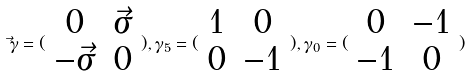Convert formula to latex. <formula><loc_0><loc_0><loc_500><loc_500>\vec { \gamma } = ( \begin{array} { c c } 0 & \vec { \sigma } \\ - \vec { \sigma } & 0 \end{array} ) , \gamma _ { 5 } = ( \begin{array} { c c } 1 & 0 \\ 0 & - 1 \end{array} ) , \gamma _ { 0 } = ( \begin{array} { c c } 0 & - 1 \\ - 1 & 0 \end{array} )</formula> 